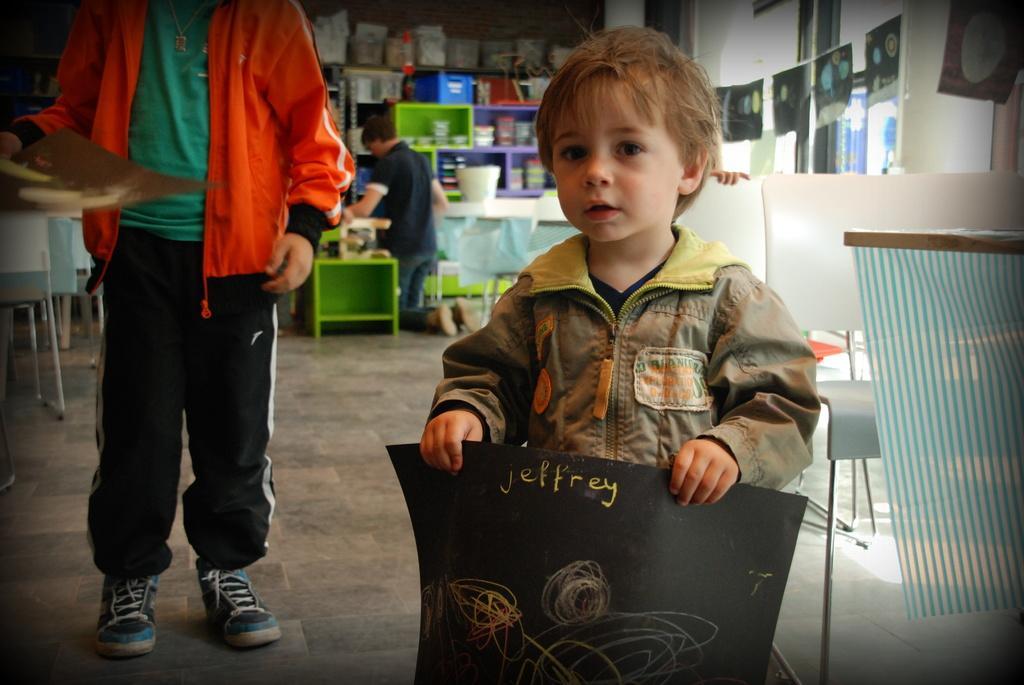Describe this image in one or two sentences. In this image we can see a boy is standing and holding black paper in his hand and he is wearing jacket. Beside one more boy is there, who is wearing green t-shirt, orange jacket with black track and holding brown paper in his hand. Background of the image one person is siting on his knee and doing some work and so many things are kept in rack. Right side of the image white color chairs are there. 